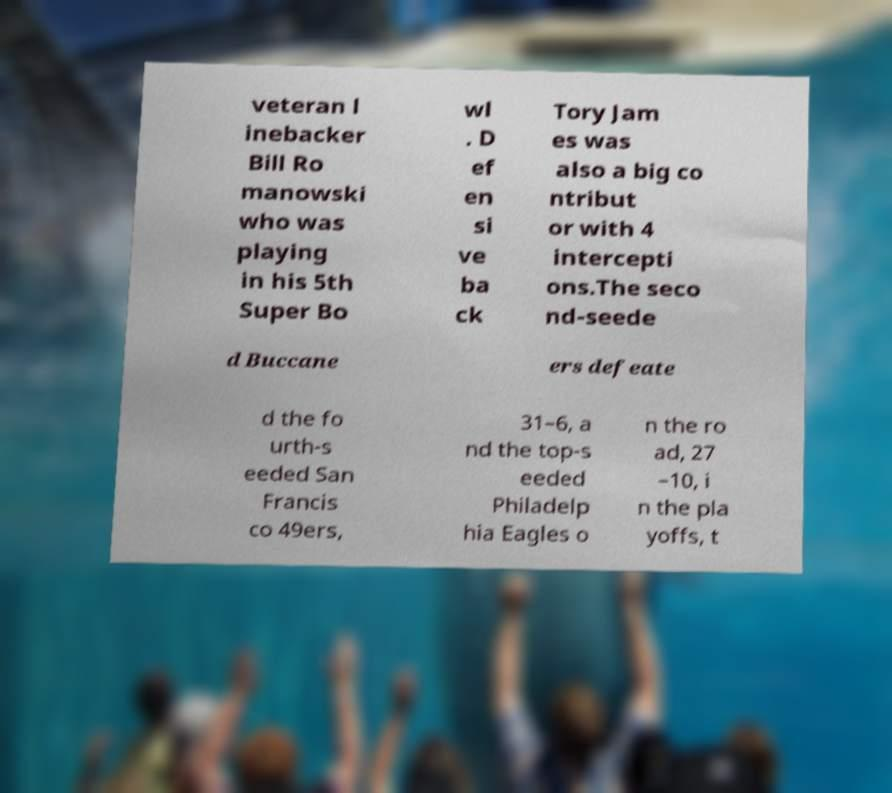Can you read and provide the text displayed in the image?This photo seems to have some interesting text. Can you extract and type it out for me? veteran l inebacker Bill Ro manowski who was playing in his 5th Super Bo wl . D ef en si ve ba ck Tory Jam es was also a big co ntribut or with 4 intercepti ons.The seco nd-seede d Buccane ers defeate d the fo urth-s eeded San Francis co 49ers, 31–6, a nd the top-s eeded Philadelp hia Eagles o n the ro ad, 27 –10, i n the pla yoffs, t 